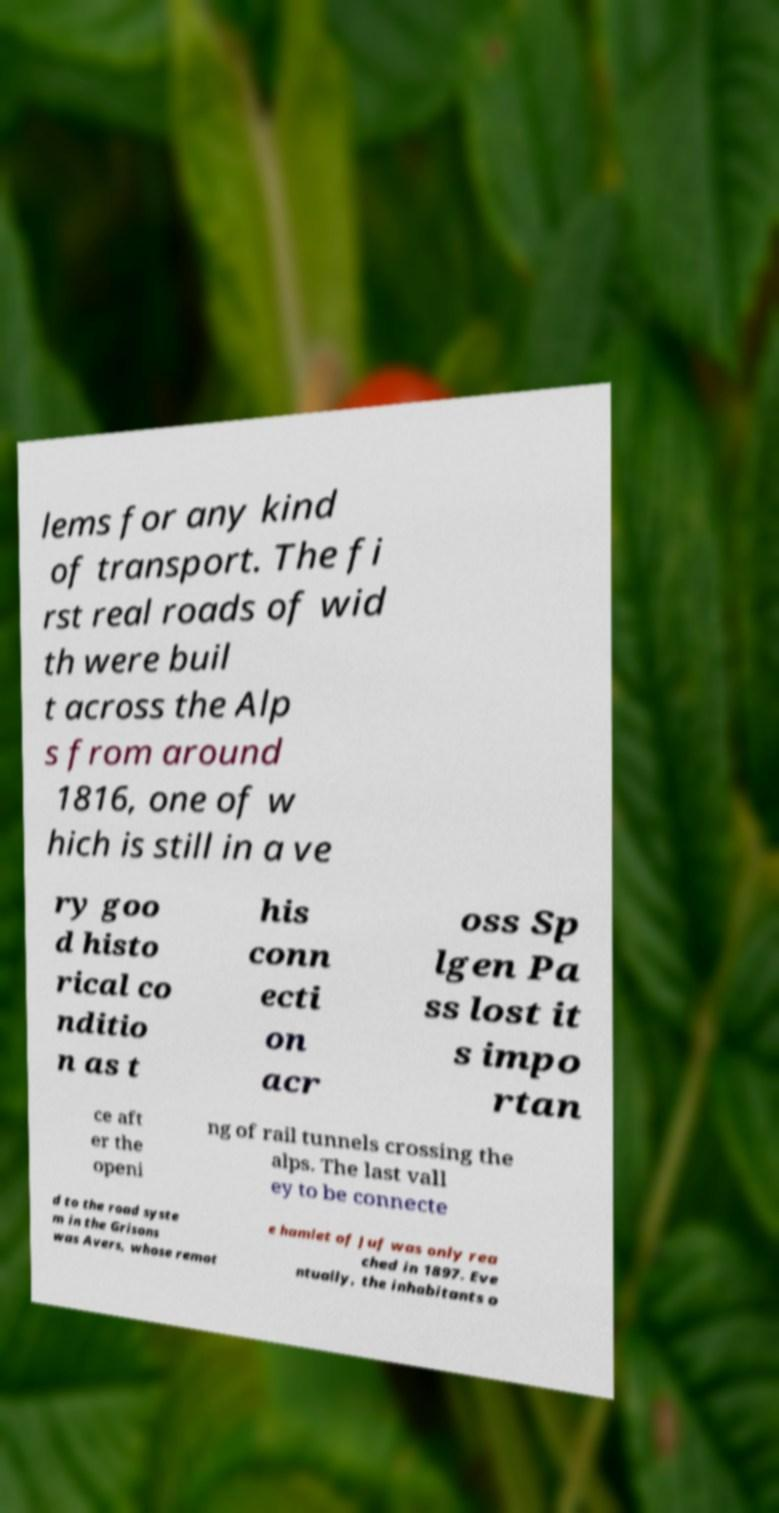Can you read and provide the text displayed in the image?This photo seems to have some interesting text. Can you extract and type it out for me? lems for any kind of transport. The fi rst real roads of wid th were buil t across the Alp s from around 1816, one of w hich is still in a ve ry goo d histo rical co nditio n as t his conn ecti on acr oss Sp lgen Pa ss lost it s impo rtan ce aft er the openi ng of rail tunnels crossing the alps. The last vall ey to be connecte d to the road syste m in the Grisons was Avers, whose remot e hamlet of Juf was only rea ched in 1897. Eve ntually, the inhabitants o 